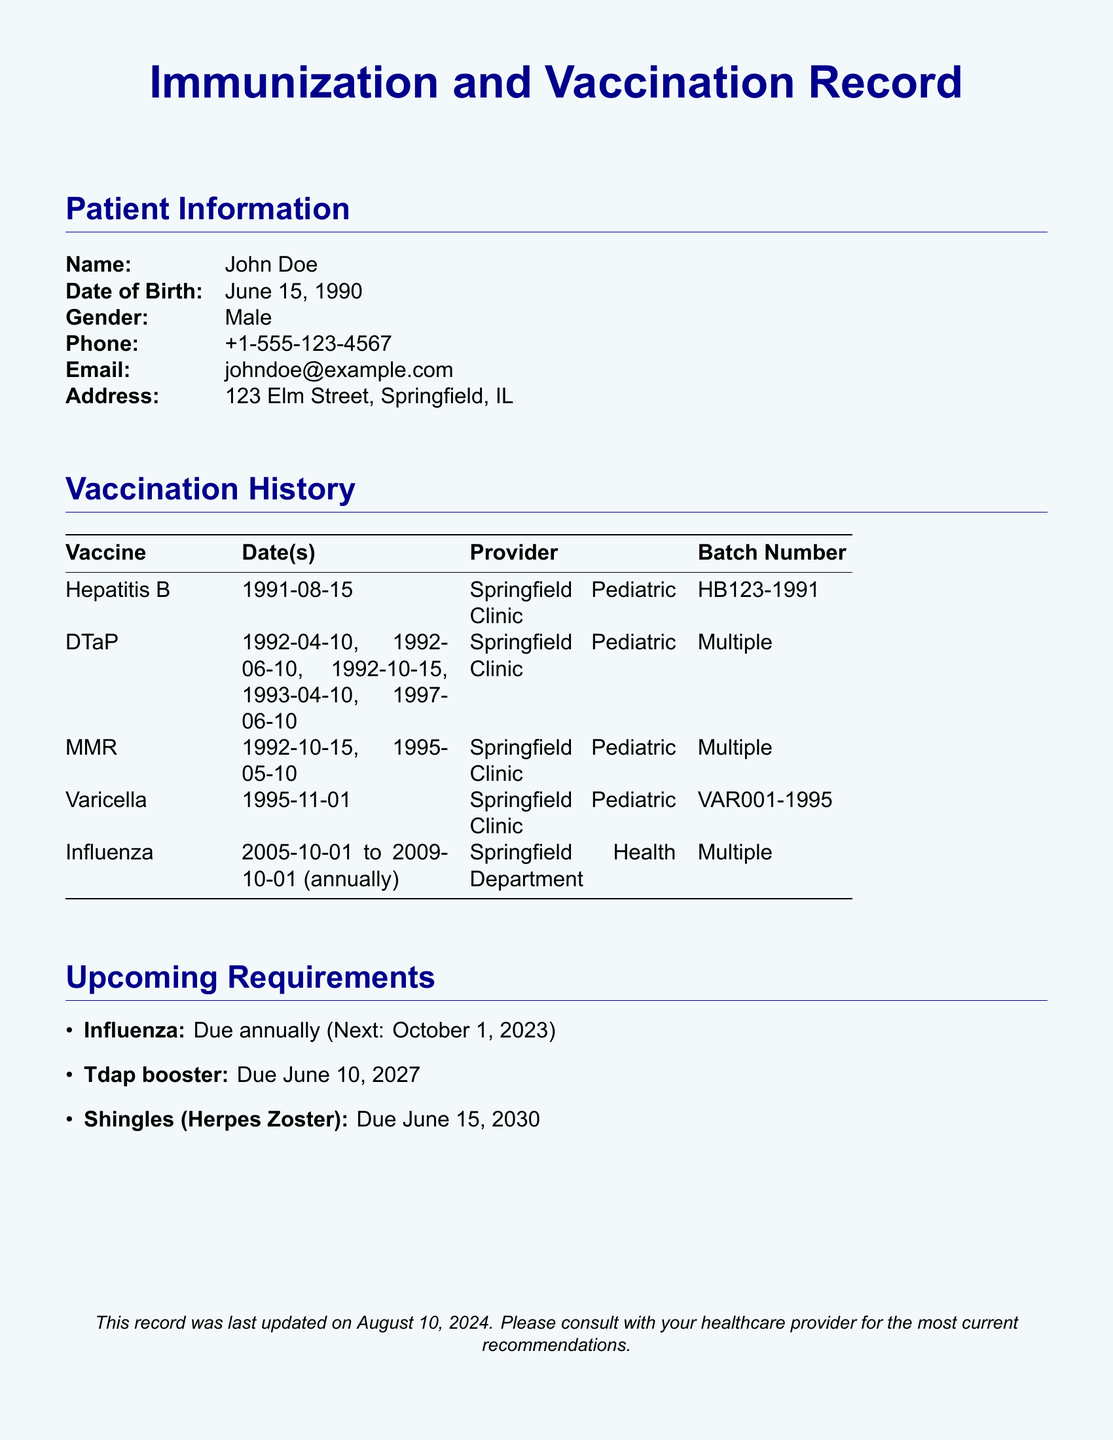What is the name of the patient? The patient's name is displayed prominently in the patient information section of the document.
Answer: John Doe What is the date of birth of the patient? The date of birth is listed in the patient information section.
Answer: June 15, 1990 How many doses of DTaP were received? The number of doses can be counted from the list of dates provided for the DTaP vaccine.
Answer: Five When is the next required influenza vaccination? The upcoming requirement section specifies the date of the next influenza vaccination.
Answer: October 1, 2023 What is the batch number for the Varicella vaccine? The batch number for the Varicella vaccine is mentioned next to it in the vaccination history.
Answer: VAR001-1995 When is the due date for the Tdap booster? The upcoming requirements section indicates the date for the Tdap booster.
Answer: June 10, 2027 Which provider administered the MMR vaccine? The vaccination history section lists the provider associated with the MMR vaccine.
Answer: Springfield Pediatric Clinic What color is the background of the document? The background color of the entire document is specified in the document's color settings.
Answer: Light blue 